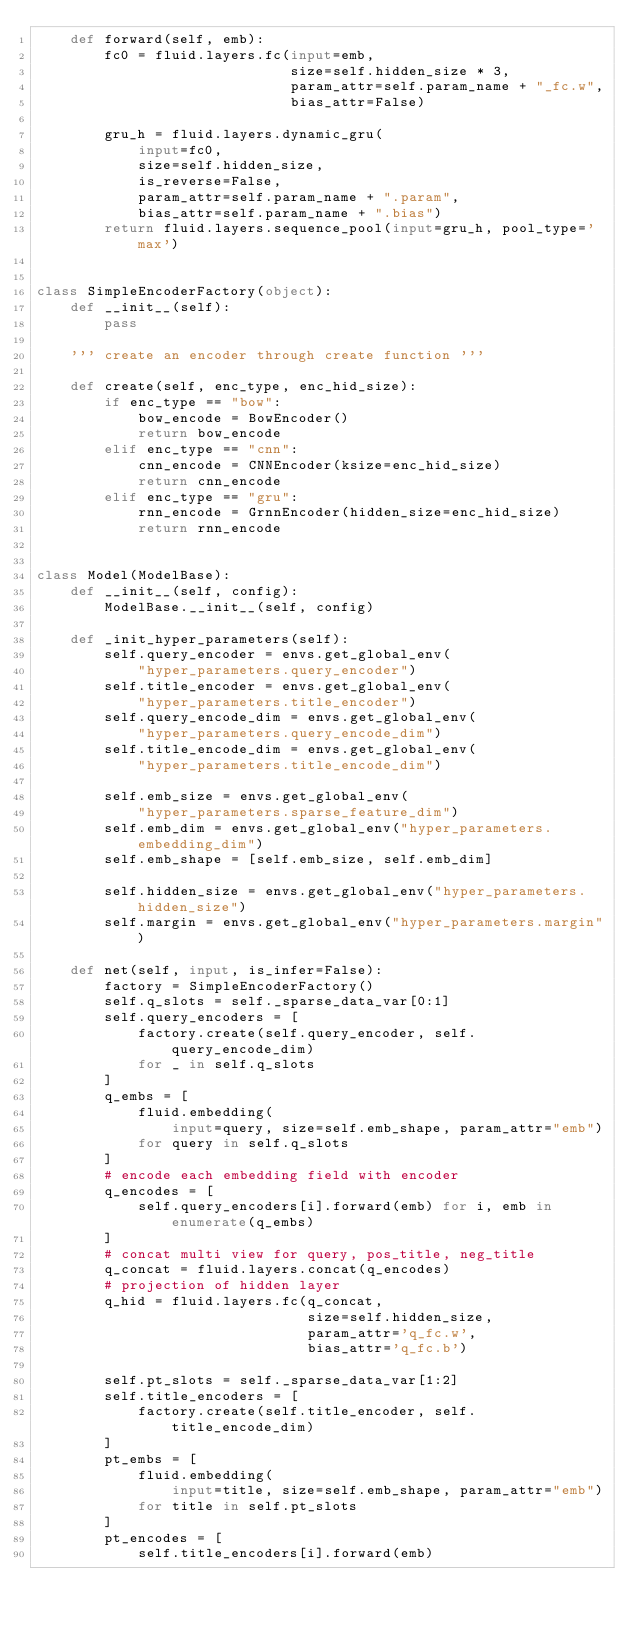Convert code to text. <code><loc_0><loc_0><loc_500><loc_500><_Python_>    def forward(self, emb):
        fc0 = fluid.layers.fc(input=emb,
                              size=self.hidden_size * 3,
                              param_attr=self.param_name + "_fc.w",
                              bias_attr=False)

        gru_h = fluid.layers.dynamic_gru(
            input=fc0,
            size=self.hidden_size,
            is_reverse=False,
            param_attr=self.param_name + ".param",
            bias_attr=self.param_name + ".bias")
        return fluid.layers.sequence_pool(input=gru_h, pool_type='max')


class SimpleEncoderFactory(object):
    def __init__(self):
        pass

    ''' create an encoder through create function '''

    def create(self, enc_type, enc_hid_size):
        if enc_type == "bow":
            bow_encode = BowEncoder()
            return bow_encode
        elif enc_type == "cnn":
            cnn_encode = CNNEncoder(ksize=enc_hid_size)
            return cnn_encode
        elif enc_type == "gru":
            rnn_encode = GrnnEncoder(hidden_size=enc_hid_size)
            return rnn_encode


class Model(ModelBase):
    def __init__(self, config):
        ModelBase.__init__(self, config)

    def _init_hyper_parameters(self):
        self.query_encoder = envs.get_global_env(
            "hyper_parameters.query_encoder")
        self.title_encoder = envs.get_global_env(
            "hyper_parameters.title_encoder")
        self.query_encode_dim = envs.get_global_env(
            "hyper_parameters.query_encode_dim")
        self.title_encode_dim = envs.get_global_env(
            "hyper_parameters.title_encode_dim")

        self.emb_size = envs.get_global_env(
            "hyper_parameters.sparse_feature_dim")
        self.emb_dim = envs.get_global_env("hyper_parameters.embedding_dim")
        self.emb_shape = [self.emb_size, self.emb_dim]

        self.hidden_size = envs.get_global_env("hyper_parameters.hidden_size")
        self.margin = envs.get_global_env("hyper_parameters.margin")

    def net(self, input, is_infer=False):
        factory = SimpleEncoderFactory()
        self.q_slots = self._sparse_data_var[0:1]
        self.query_encoders = [
            factory.create(self.query_encoder, self.query_encode_dim)
            for _ in self.q_slots
        ]
        q_embs = [
            fluid.embedding(
                input=query, size=self.emb_shape, param_attr="emb")
            for query in self.q_slots
        ]
        # encode each embedding field with encoder
        q_encodes = [
            self.query_encoders[i].forward(emb) for i, emb in enumerate(q_embs)
        ]
        # concat multi view for query, pos_title, neg_title
        q_concat = fluid.layers.concat(q_encodes)
        # projection of hidden layer
        q_hid = fluid.layers.fc(q_concat,
                                size=self.hidden_size,
                                param_attr='q_fc.w',
                                bias_attr='q_fc.b')

        self.pt_slots = self._sparse_data_var[1:2]
        self.title_encoders = [
            factory.create(self.title_encoder, self.title_encode_dim)
        ]
        pt_embs = [
            fluid.embedding(
                input=title, size=self.emb_shape, param_attr="emb")
            for title in self.pt_slots
        ]
        pt_encodes = [
            self.title_encoders[i].forward(emb)</code> 